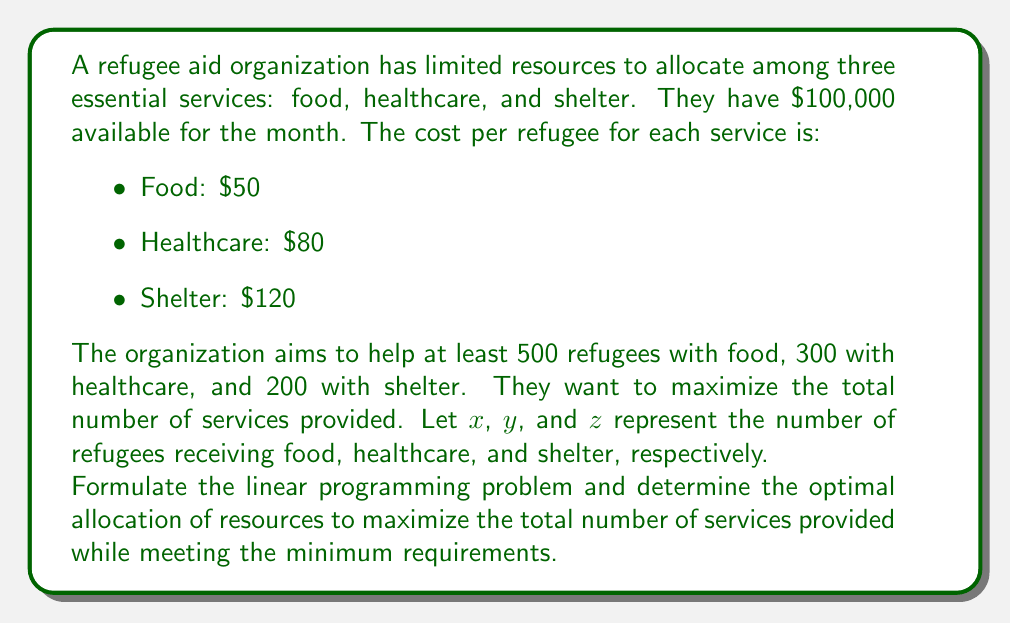Help me with this question. To solve this problem, we'll follow these steps:

1. Define the objective function:
   Maximize $f(x,y,z) = x + y + z$

2. Set up the constraints:
   a) Budget constraint: $50x + 80y + 120z \leq 100000$
   b) Minimum requirements:
      $x \geq 500$
      $y \geq 300$
      $z \geq 200$
   c) Non-negativity: $x, y, z \geq 0$

3. Solve using the simplex method or linear programming software.

4. The optimal solution is:
   $x = 500$ (food)
   $y = 300$ (healthcare)
   $z = 458$ (shelter)

5. Verify the solution:
   Budget used: $50(500) + 80(300) + 120(458) = 25000 + 24000 + 54960 = 103960$
   This is slightly over budget, so we need to adjust $z$.

6. Adjust $z$:
   $z = \frac{100000 - 25000 - 24000}{120} = 425$

7. Final optimal solution:
   $x = 500$ (food)
   $y = 300$ (healthcare)
   $z = 425$ (shelter)

8. Verify final solution:
   Budget used: $50(500) + 80(300) + 120(425) = 25000 + 24000 + 51000 = 100000$
   Total services provided: $500 + 300 + 425 = 1225$

This allocation maximizes the total number of services provided while meeting all constraints.
Answer: $x = 500$, $y = 300$, $z = 425$ 